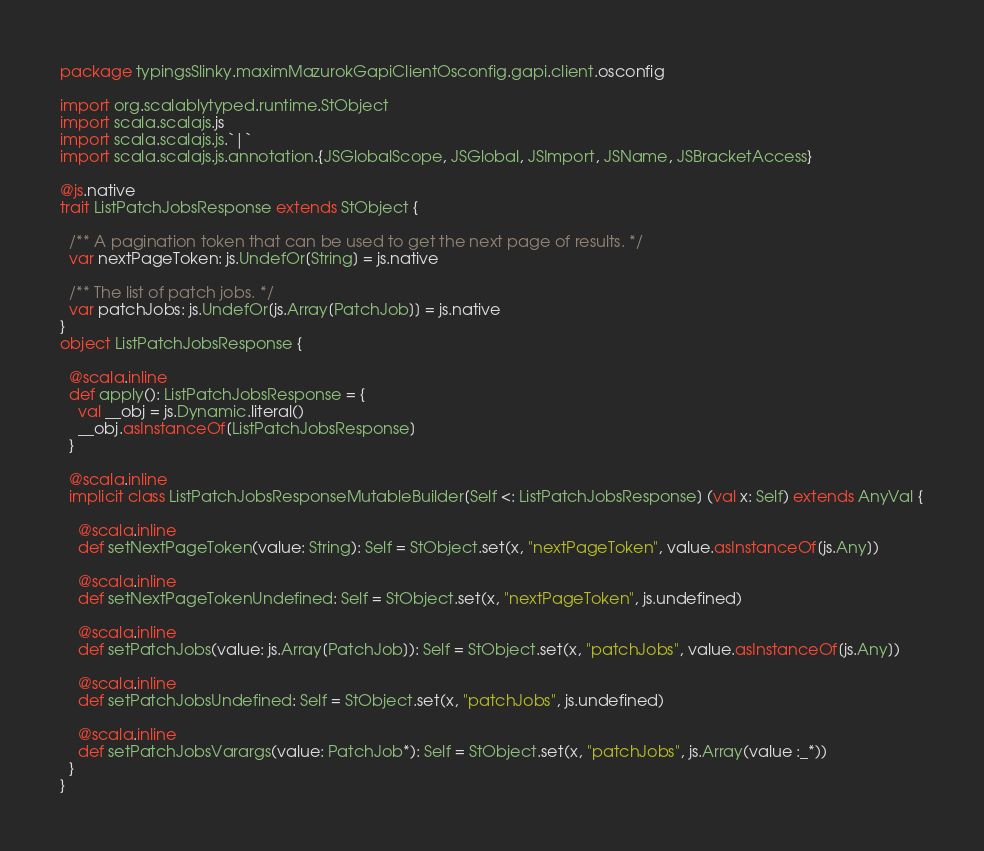Convert code to text. <code><loc_0><loc_0><loc_500><loc_500><_Scala_>package typingsSlinky.maximMazurokGapiClientOsconfig.gapi.client.osconfig

import org.scalablytyped.runtime.StObject
import scala.scalajs.js
import scala.scalajs.js.`|`
import scala.scalajs.js.annotation.{JSGlobalScope, JSGlobal, JSImport, JSName, JSBracketAccess}

@js.native
trait ListPatchJobsResponse extends StObject {
  
  /** A pagination token that can be used to get the next page of results. */
  var nextPageToken: js.UndefOr[String] = js.native
  
  /** The list of patch jobs. */
  var patchJobs: js.UndefOr[js.Array[PatchJob]] = js.native
}
object ListPatchJobsResponse {
  
  @scala.inline
  def apply(): ListPatchJobsResponse = {
    val __obj = js.Dynamic.literal()
    __obj.asInstanceOf[ListPatchJobsResponse]
  }
  
  @scala.inline
  implicit class ListPatchJobsResponseMutableBuilder[Self <: ListPatchJobsResponse] (val x: Self) extends AnyVal {
    
    @scala.inline
    def setNextPageToken(value: String): Self = StObject.set(x, "nextPageToken", value.asInstanceOf[js.Any])
    
    @scala.inline
    def setNextPageTokenUndefined: Self = StObject.set(x, "nextPageToken", js.undefined)
    
    @scala.inline
    def setPatchJobs(value: js.Array[PatchJob]): Self = StObject.set(x, "patchJobs", value.asInstanceOf[js.Any])
    
    @scala.inline
    def setPatchJobsUndefined: Self = StObject.set(x, "patchJobs", js.undefined)
    
    @scala.inline
    def setPatchJobsVarargs(value: PatchJob*): Self = StObject.set(x, "patchJobs", js.Array(value :_*))
  }
}
</code> 